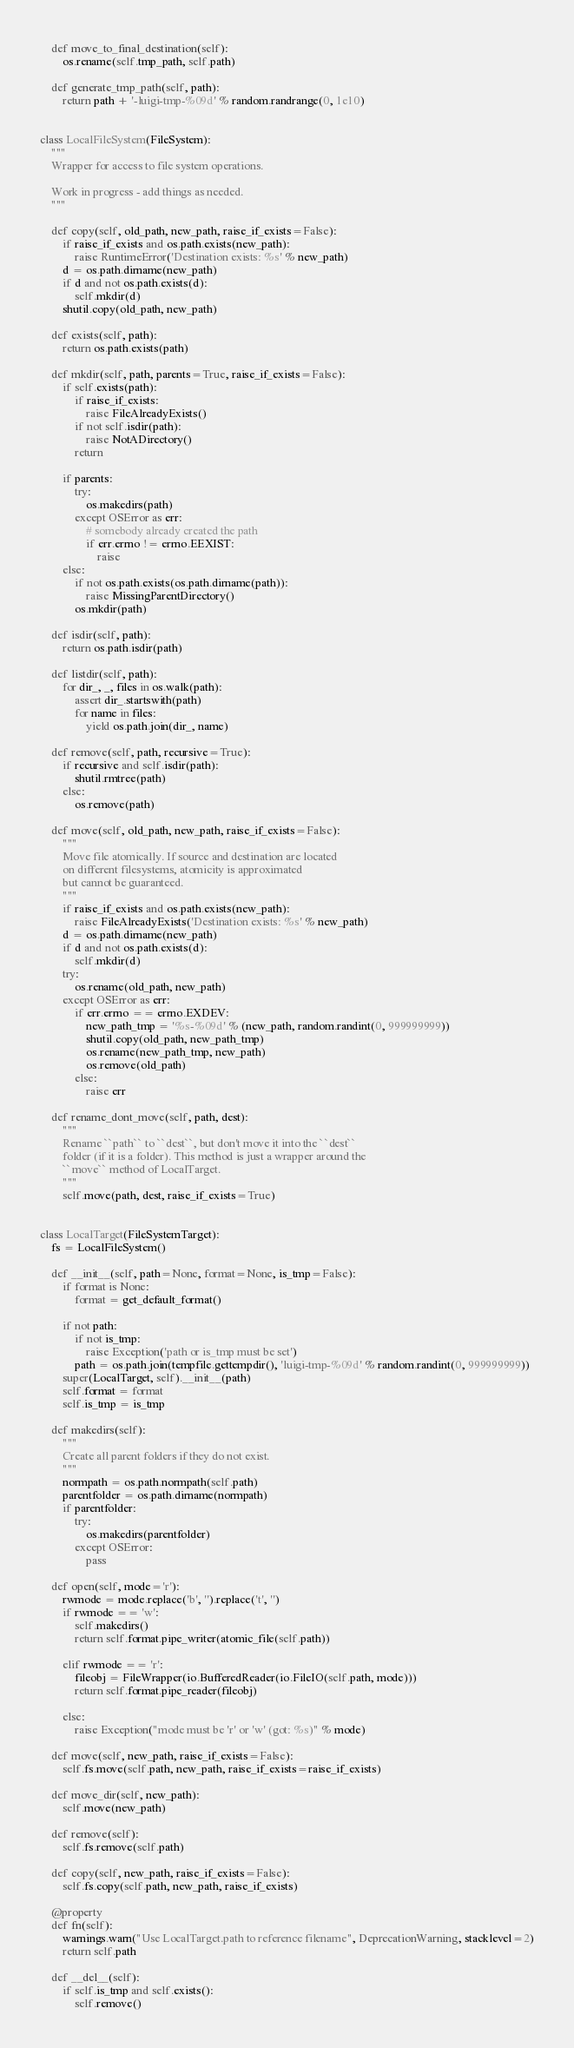<code> <loc_0><loc_0><loc_500><loc_500><_Python_>    def move_to_final_destination(self):
        os.rename(self.tmp_path, self.path)

    def generate_tmp_path(self, path):
        return path + '-luigi-tmp-%09d' % random.randrange(0, 1e10)


class LocalFileSystem(FileSystem):
    """
    Wrapper for access to file system operations.

    Work in progress - add things as needed.
    """

    def copy(self, old_path, new_path, raise_if_exists=False):
        if raise_if_exists and os.path.exists(new_path):
            raise RuntimeError('Destination exists: %s' % new_path)
        d = os.path.dirname(new_path)
        if d and not os.path.exists(d):
            self.mkdir(d)
        shutil.copy(old_path, new_path)

    def exists(self, path):
        return os.path.exists(path)

    def mkdir(self, path, parents=True, raise_if_exists=False):
        if self.exists(path):
            if raise_if_exists:
                raise FileAlreadyExists()
            if not self.isdir(path):
                raise NotADirectory()
            return

        if parents:
            try:
                os.makedirs(path)
            except OSError as err:
                # somebody already created the path
                if err.errno != errno.EEXIST:
                    raise
        else:
            if not os.path.exists(os.path.dirname(path)):
                raise MissingParentDirectory()
            os.mkdir(path)

    def isdir(self, path):
        return os.path.isdir(path)

    def listdir(self, path):
        for dir_, _, files in os.walk(path):
            assert dir_.startswith(path)
            for name in files:
                yield os.path.join(dir_, name)

    def remove(self, path, recursive=True):
        if recursive and self.isdir(path):
            shutil.rmtree(path)
        else:
            os.remove(path)

    def move(self, old_path, new_path, raise_if_exists=False):
        """
        Move file atomically. If source and destination are located
        on different filesystems, atomicity is approximated
        but cannot be guaranteed.
        """
        if raise_if_exists and os.path.exists(new_path):
            raise FileAlreadyExists('Destination exists: %s' % new_path)
        d = os.path.dirname(new_path)
        if d and not os.path.exists(d):
            self.mkdir(d)
        try:
            os.rename(old_path, new_path)
        except OSError as err:
            if err.errno == errno.EXDEV:
                new_path_tmp = '%s-%09d' % (new_path, random.randint(0, 999999999))
                shutil.copy(old_path, new_path_tmp)
                os.rename(new_path_tmp, new_path)
                os.remove(old_path)
            else:
                raise err

    def rename_dont_move(self, path, dest):
        """
        Rename ``path`` to ``dest``, but don't move it into the ``dest``
        folder (if it is a folder). This method is just a wrapper around the
        ``move`` method of LocalTarget.
        """
        self.move(path, dest, raise_if_exists=True)


class LocalTarget(FileSystemTarget):
    fs = LocalFileSystem()

    def __init__(self, path=None, format=None, is_tmp=False):
        if format is None:
            format = get_default_format()

        if not path:
            if not is_tmp:
                raise Exception('path or is_tmp must be set')
            path = os.path.join(tempfile.gettempdir(), 'luigi-tmp-%09d' % random.randint(0, 999999999))
        super(LocalTarget, self).__init__(path)
        self.format = format
        self.is_tmp = is_tmp

    def makedirs(self):
        """
        Create all parent folders if they do not exist.
        """
        normpath = os.path.normpath(self.path)
        parentfolder = os.path.dirname(normpath)
        if parentfolder:
            try:
                os.makedirs(parentfolder)
            except OSError:
                pass

    def open(self, mode='r'):
        rwmode = mode.replace('b', '').replace('t', '')
        if rwmode == 'w':
            self.makedirs()
            return self.format.pipe_writer(atomic_file(self.path))

        elif rwmode == 'r':
            fileobj = FileWrapper(io.BufferedReader(io.FileIO(self.path, mode)))
            return self.format.pipe_reader(fileobj)

        else:
            raise Exception("mode must be 'r' or 'w' (got: %s)" % mode)

    def move(self, new_path, raise_if_exists=False):
        self.fs.move(self.path, new_path, raise_if_exists=raise_if_exists)

    def move_dir(self, new_path):
        self.move(new_path)

    def remove(self):
        self.fs.remove(self.path)

    def copy(self, new_path, raise_if_exists=False):
        self.fs.copy(self.path, new_path, raise_if_exists)

    @property
    def fn(self):
        warnings.warn("Use LocalTarget.path to reference filename", DeprecationWarning, stacklevel=2)
        return self.path

    def __del__(self):
        if self.is_tmp and self.exists():
            self.remove()
</code> 